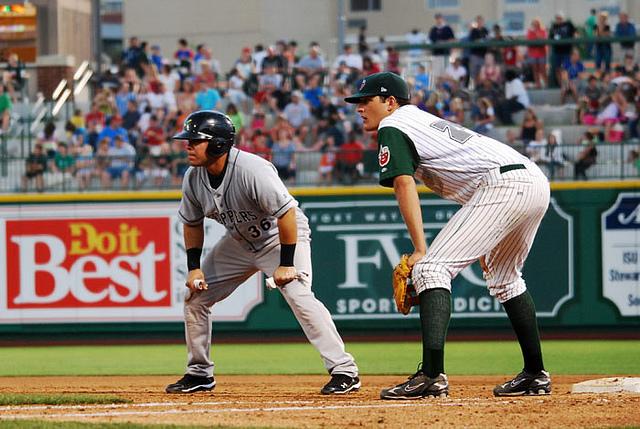What is the man holding?
Short answer required. Glove. What word is under "do it"?
Keep it brief. Best. Which player is the offensive player?
Write a very short answer. Left. What sport is this?
Answer briefly. Baseball. 